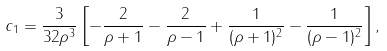<formula> <loc_0><loc_0><loc_500><loc_500>c _ { 1 } = \frac { 3 } { 3 2 \rho ^ { 3 } } \left [ - \frac { 2 } { \rho + 1 } - \frac { 2 } { \rho - 1 } + \frac { 1 } { ( \rho + 1 ) ^ { 2 } } - \frac { 1 } { ( \rho - 1 ) ^ { 2 } } \right ] ,</formula> 